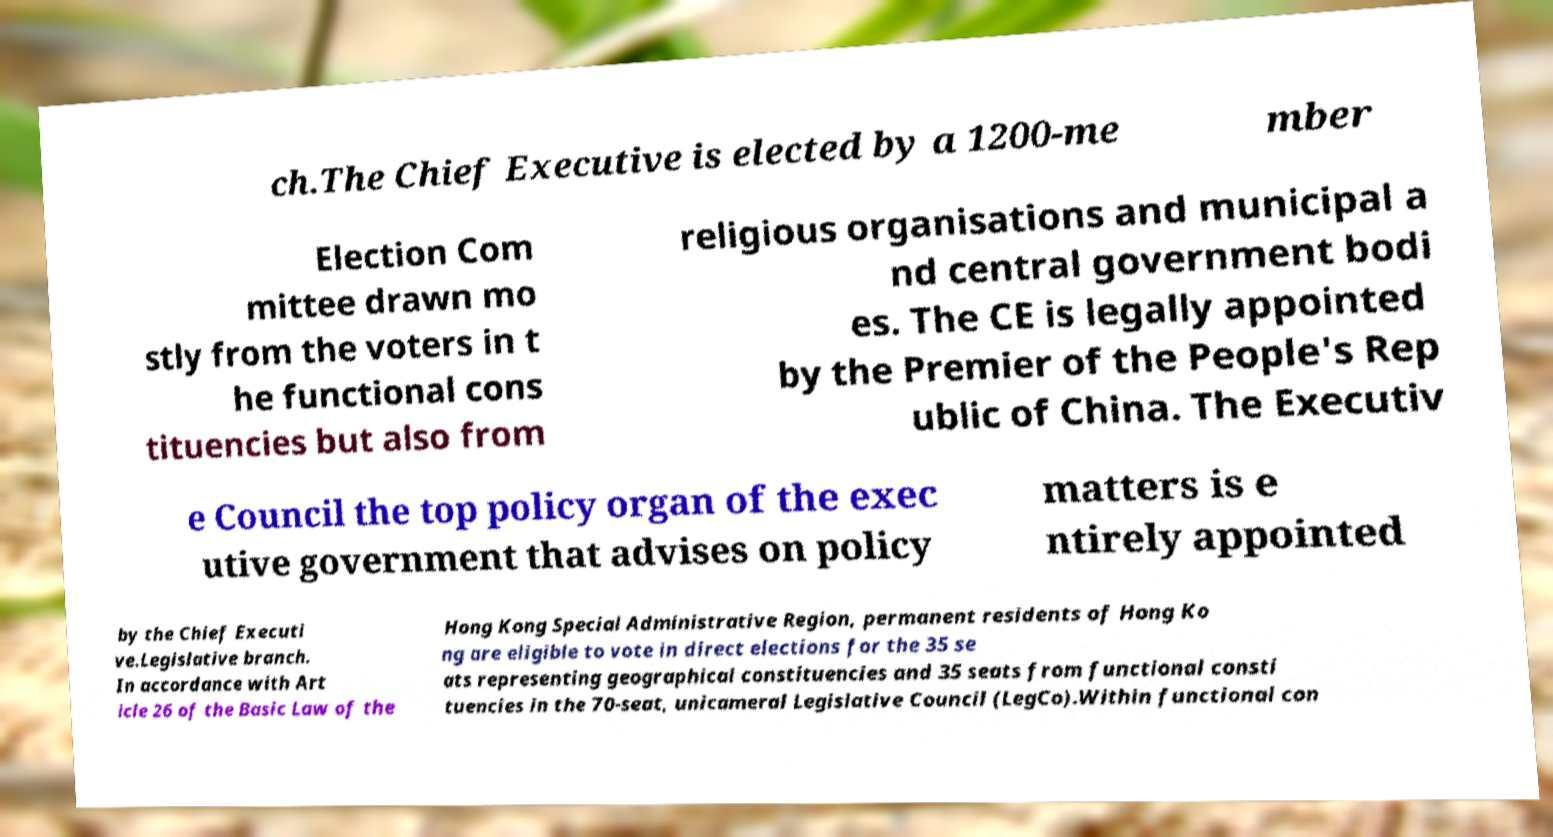Could you assist in decoding the text presented in this image and type it out clearly? ch.The Chief Executive is elected by a 1200-me mber Election Com mittee drawn mo stly from the voters in t he functional cons tituencies but also from religious organisations and municipal a nd central government bodi es. The CE is legally appointed by the Premier of the People's Rep ublic of China. The Executiv e Council the top policy organ of the exec utive government that advises on policy matters is e ntirely appointed by the Chief Executi ve.Legislative branch. In accordance with Art icle 26 of the Basic Law of the Hong Kong Special Administrative Region, permanent residents of Hong Ko ng are eligible to vote in direct elections for the 35 se ats representing geographical constituencies and 35 seats from functional consti tuencies in the 70-seat, unicameral Legislative Council (LegCo).Within functional con 